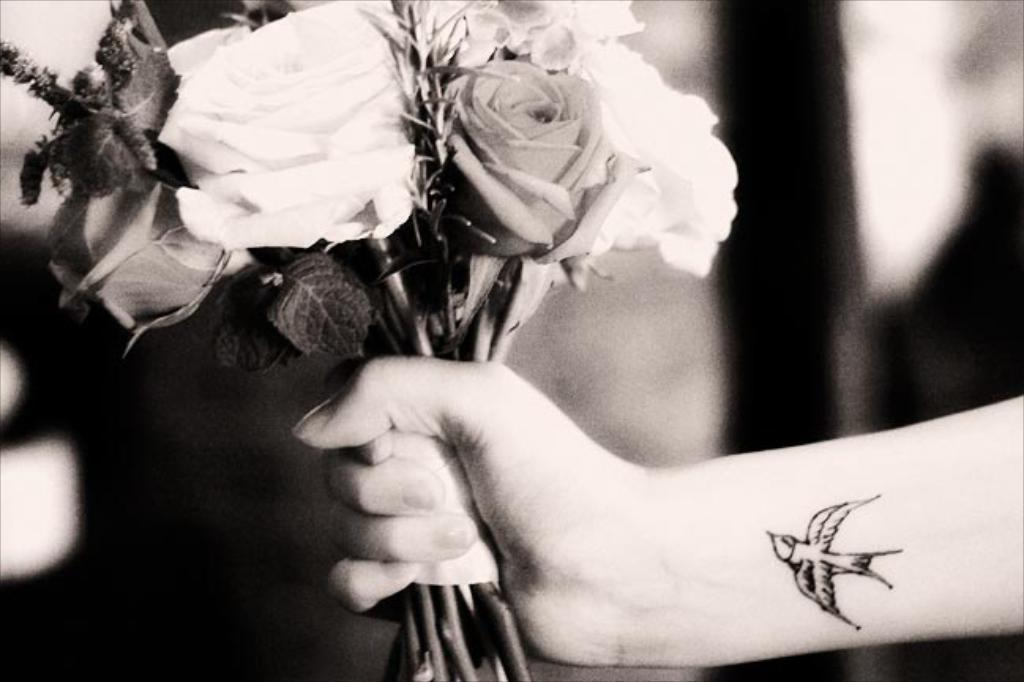What part of the person's body is visible in the image? There is a person's hand in the image. What is the person holding in the image? The person is holding a flower bouquet. Can you describe any additional features on the person's hand? The person has a tattoo on their hand. What time of day does the person feel the most shame in the image? There is no indication of time or feelings of shame in the image; it only shows a person's hand holding a flower bouquet and displaying a tattoo. 